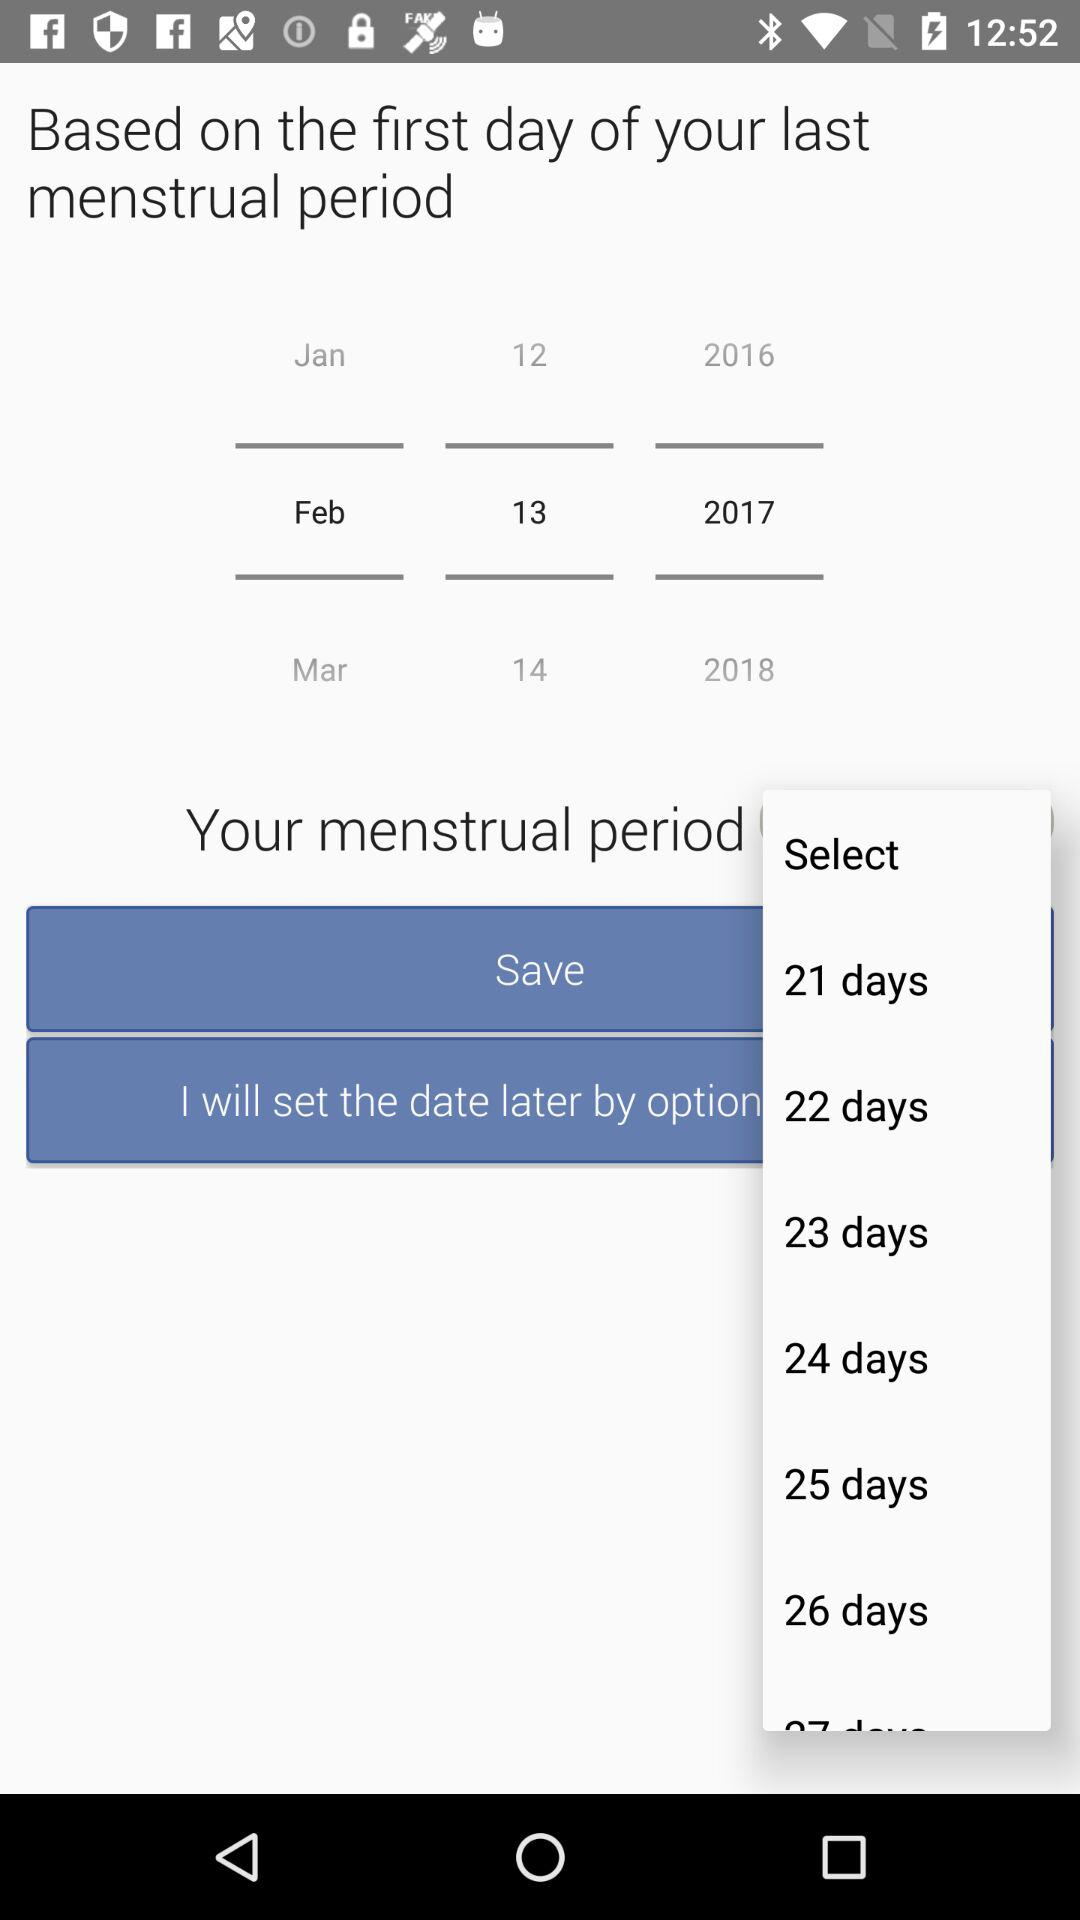Which is the first day of the last menstrual period? The first day of the last menstrual period is February 13, 2017. 